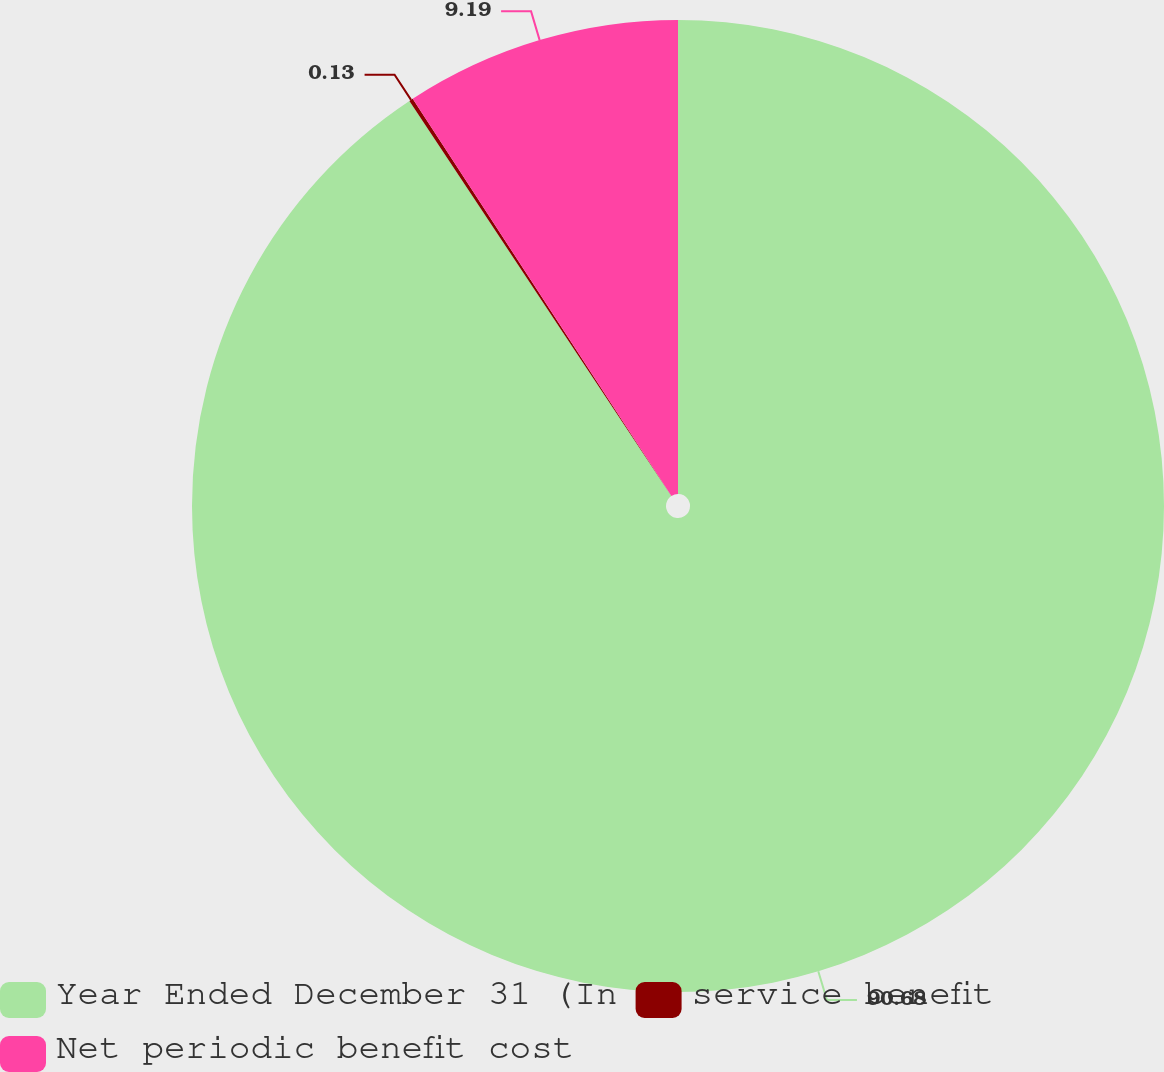<chart> <loc_0><loc_0><loc_500><loc_500><pie_chart><fcel>Year Ended December 31 (In<fcel>service benefit<fcel>Net periodic benefit cost<nl><fcel>90.68%<fcel>0.13%<fcel>9.19%<nl></chart> 